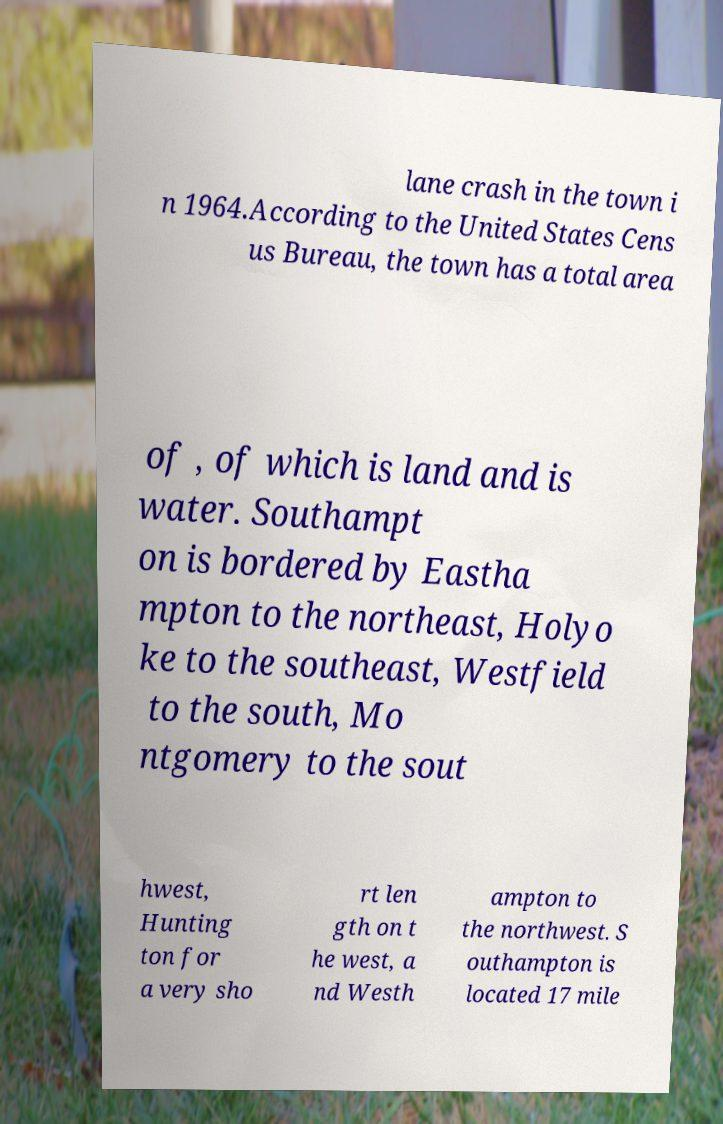There's text embedded in this image that I need extracted. Can you transcribe it verbatim? lane crash in the town i n 1964.According to the United States Cens us Bureau, the town has a total area of , of which is land and is water. Southampt on is bordered by Eastha mpton to the northeast, Holyo ke to the southeast, Westfield to the south, Mo ntgomery to the sout hwest, Hunting ton for a very sho rt len gth on t he west, a nd Westh ampton to the northwest. S outhampton is located 17 mile 